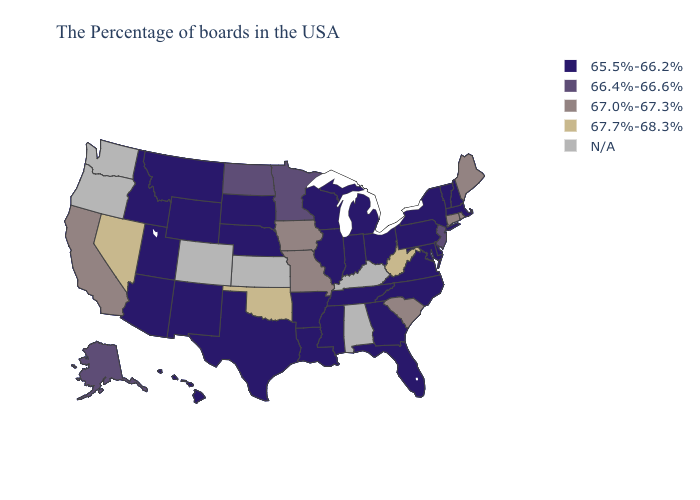Among the states that border Kentucky , does Missouri have the lowest value?
Short answer required. No. Name the states that have a value in the range 67.0%-67.3%?
Concise answer only. Maine, Rhode Island, Connecticut, South Carolina, Missouri, Iowa, California. Does Utah have the lowest value in the USA?
Quick response, please. Yes. Does the first symbol in the legend represent the smallest category?
Quick response, please. Yes. Name the states that have a value in the range 67.0%-67.3%?
Be succinct. Maine, Rhode Island, Connecticut, South Carolina, Missouri, Iowa, California. What is the highest value in the USA?
Be succinct. 67.7%-68.3%. What is the value of Wyoming?
Give a very brief answer. 65.5%-66.2%. Name the states that have a value in the range N/A?
Short answer required. Kentucky, Alabama, Kansas, Colorado, Washington, Oregon. What is the lowest value in the USA?
Be succinct. 65.5%-66.2%. Name the states that have a value in the range 67.7%-68.3%?
Answer briefly. West Virginia, Oklahoma, Nevada. What is the value of North Carolina?
Write a very short answer. 65.5%-66.2%. Does Wisconsin have the lowest value in the USA?
Answer briefly. Yes. What is the value of Wyoming?
Concise answer only. 65.5%-66.2%. Which states hav the highest value in the MidWest?
Quick response, please. Missouri, Iowa. Does the first symbol in the legend represent the smallest category?
Quick response, please. Yes. 